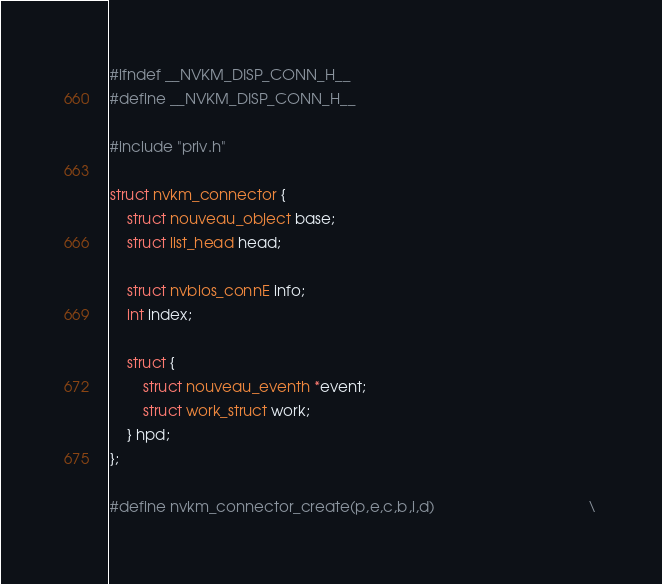<code> <loc_0><loc_0><loc_500><loc_500><_C_>#ifndef __NVKM_DISP_CONN_H__
#define __NVKM_DISP_CONN_H__

#include "priv.h"

struct nvkm_connector {
	struct nouveau_object base;
	struct list_head head;

	struct nvbios_connE info;
	int index;

	struct {
		struct nouveau_eventh *event;
		struct work_struct work;
	} hpd;
};

#define nvkm_connector_create(p,e,c,b,i,d)                                     \</code> 